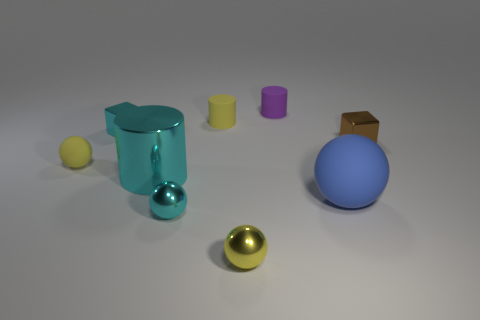Are the tiny purple cylinder and the yellow thing that is behind the tiny yellow rubber sphere made of the same material?
Offer a very short reply. Yes. The large shiny object is what color?
Keep it short and to the point. Cyan. What size is the cylinder that is the same material as the purple object?
Your answer should be compact. Small. There is a small metallic cube to the right of the small metallic block that is left of the small purple thing; how many big cylinders are in front of it?
Your answer should be compact. 1. There is a metal cylinder; does it have the same color as the cube that is left of the tiny purple cylinder?
Provide a short and direct response. Yes. There is a matte object that is the same color as the tiny rubber sphere; what is its shape?
Ensure brevity in your answer.  Cylinder. There is a big thing right of the yellow sphere that is on the right side of the tiny yellow matte thing that is to the left of the small cyan metal cube; what is its material?
Your answer should be very brief. Rubber. There is a big object behind the big blue matte thing; does it have the same shape as the purple object?
Give a very brief answer. Yes. There is a sphere behind the large blue rubber sphere; what is it made of?
Your answer should be compact. Rubber. How many metal things are big balls or cyan cylinders?
Your answer should be compact. 1. 